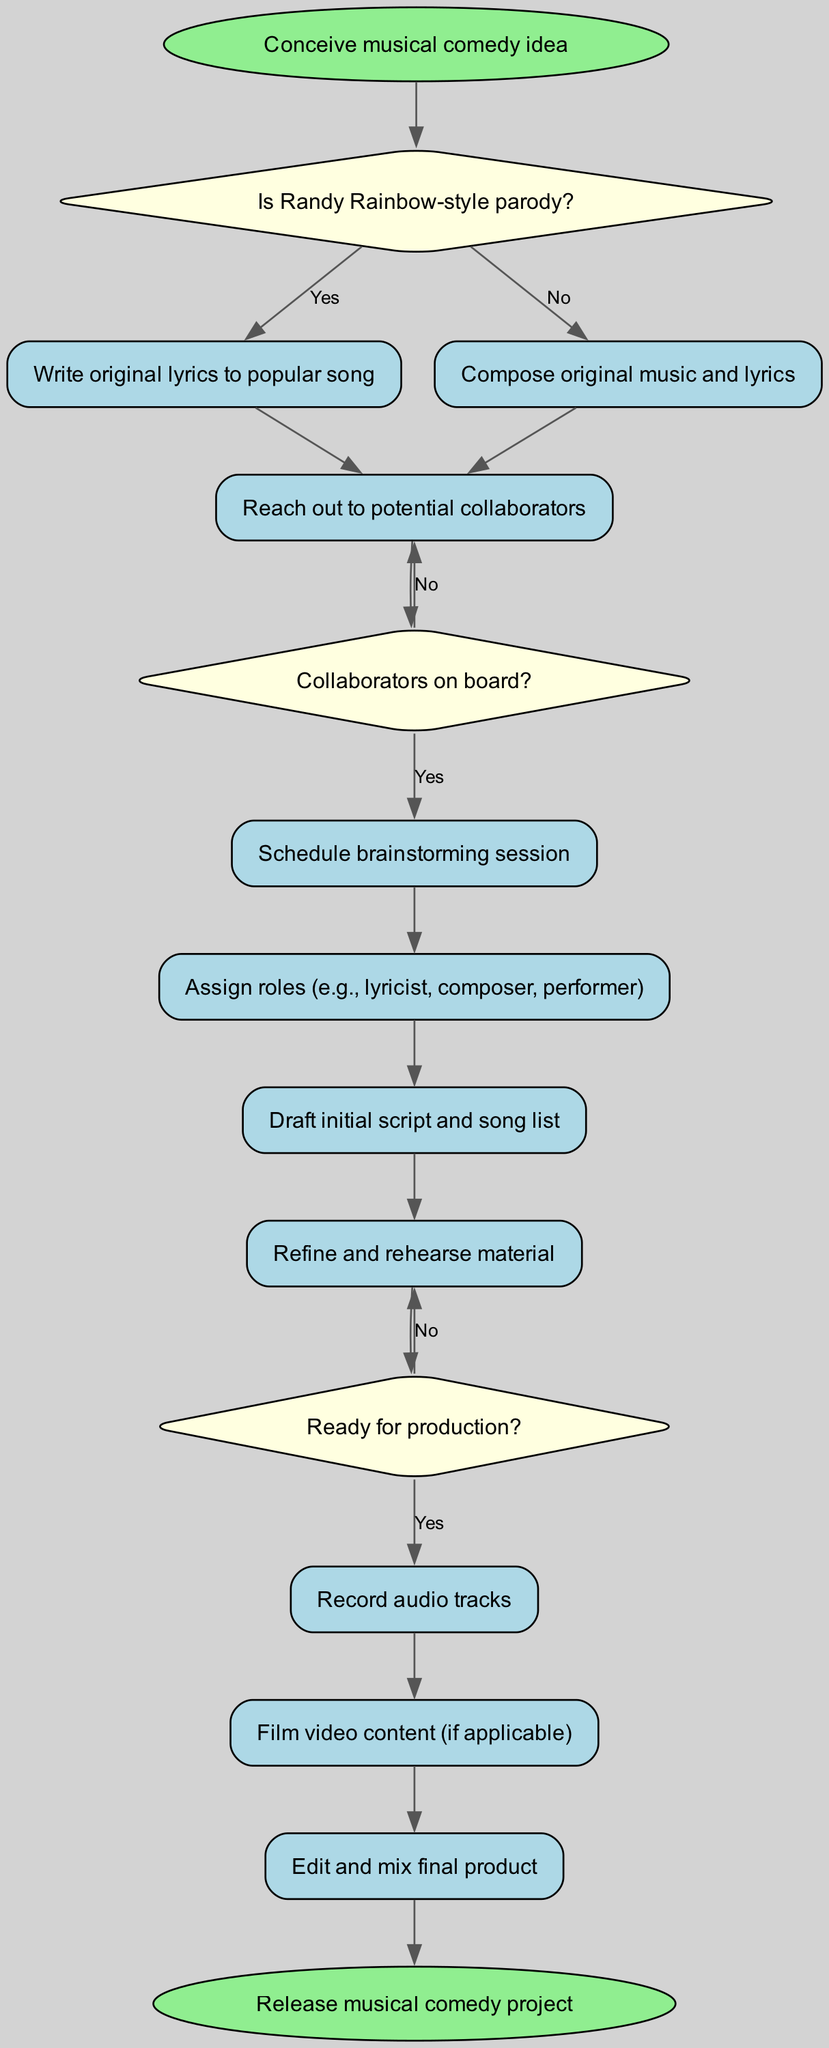What is the starting point of the process? The starting point is represented by the 'start' node, which states "Conceive musical comedy idea." This is the first action to be taken in the process diagram.
Answer: Conceive musical comedy idea How many decision nodes are in the diagram? The diagram contains three decision nodes, identified by the keys 'decision1', 'decision2', and 'decision3'. These nodes are where choices are made.
Answer: 3 What happens if collaborators are not on board? If collaborators are not on board (No response from 'decision2'), the process loops back to 'process3', which is "Reach out to potential collaborators," indicating that the team will try to contact more artists or collaborators again.
Answer: Reach out to potential collaborators After refining and rehearsing material, what is the next decision point? After 'process7', which is "Refine and rehearse material," the process moves to 'decision3', where it asks "Ready for production?" This decision dictates whether to proceed with production or continue refining.
Answer: Ready for production? What is the final step in the process? The final step is the 'end' node, which states "Release musical comedy project." This indicates the completion of the entire process as it leads to the final deliverable.
Answer: Release musical comedy project If the answer at decision1 is yes, what is the immediate next process? If the answer at 'decision1' is yes, the next process is 'process1', which involves writing original lyrics to a popular song. This action follows the confirmation that the project is a Randy Rainbow-style parody.
Answer: Write original lyrics to popular song What is assigned after scheduling a brainstorming session? After 'process4', which is "Schedule brainstorming session," the next action is 'process5', which involves assigning roles like lyricist, composer, and performer. This step helps define responsibilities in the collaboration.
Answer: Assign roles Which process involves editing and mixing? The diagram shows that 'process10', titled "Edit and mix final product," is where the editing and mixing of the audio tracks and video content occur, making it a crucial step for finalizing the project.
Answer: Edit and mix final product 